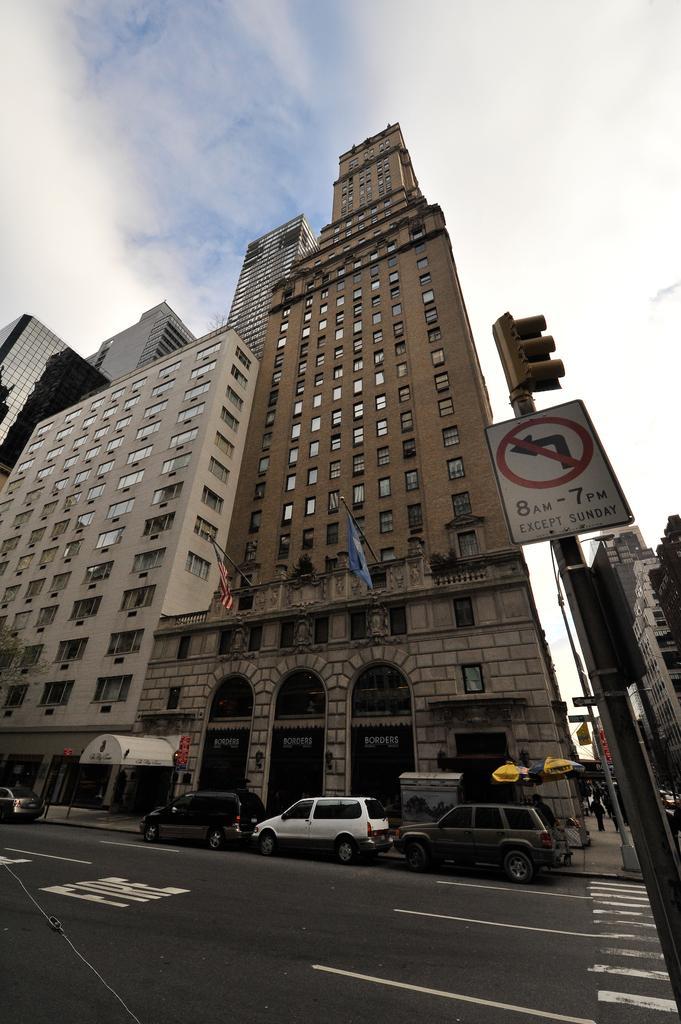Can you describe this image briefly? On the right side, there are signal lights and sign boards attached to the pole near zebra crossing which is on the road on which, there are vehicles parked aside. In the background, there are buildings and there are clouds in the blue sky. 